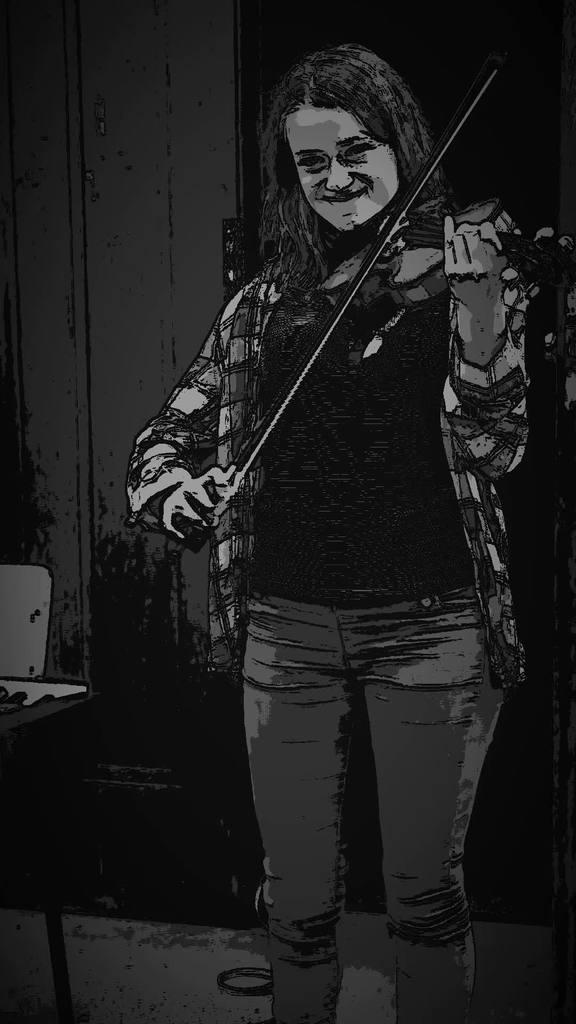Could you give a brief overview of what you see in this image? In this image I can see a woman playing a musical instrument. 